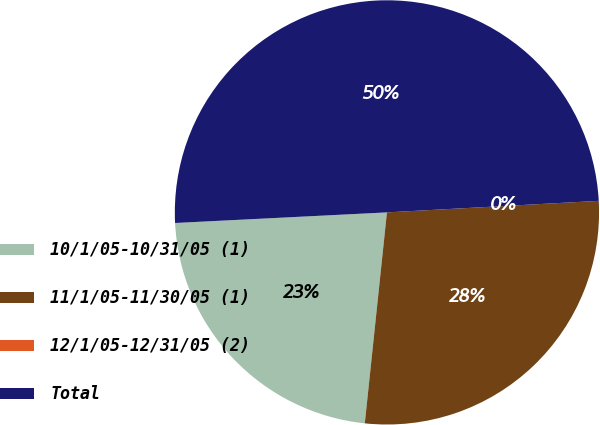Convert chart. <chart><loc_0><loc_0><loc_500><loc_500><pie_chart><fcel>10/1/05-10/31/05 (1)<fcel>11/1/05-11/30/05 (1)<fcel>12/1/05-12/31/05 (2)<fcel>Total<nl><fcel>22.54%<fcel>27.53%<fcel>0.0%<fcel>49.93%<nl></chart> 